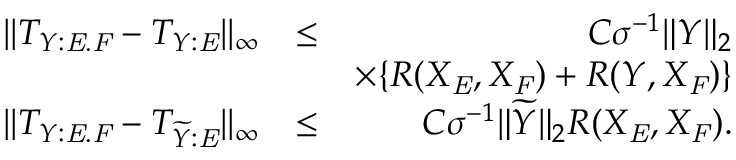<formula> <loc_0><loc_0><loc_500><loc_500>\begin{array} { r l r } { | | T _ { Y \colon E . F } - T _ { Y \colon E } | | _ { \infty } } & { \leq } & { C \sigma ^ { - 1 } \| Y \| _ { 2 } } \\ & { \times \{ R ( X _ { E } , X _ { F } ) + R ( Y , X _ { F } ) \} } \\ { | | T _ { Y \colon E . F } - T _ { \widetilde { Y } \colon E } | | _ { \infty } } & { \leq } & { C \sigma ^ { - 1 } \| \widetilde { Y } \| _ { 2 } R ( X _ { E } , X _ { F } ) . } \end{array}</formula> 